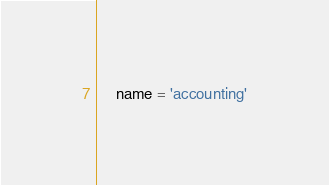<code> <loc_0><loc_0><loc_500><loc_500><_Python_>    name = 'accounting'
</code> 